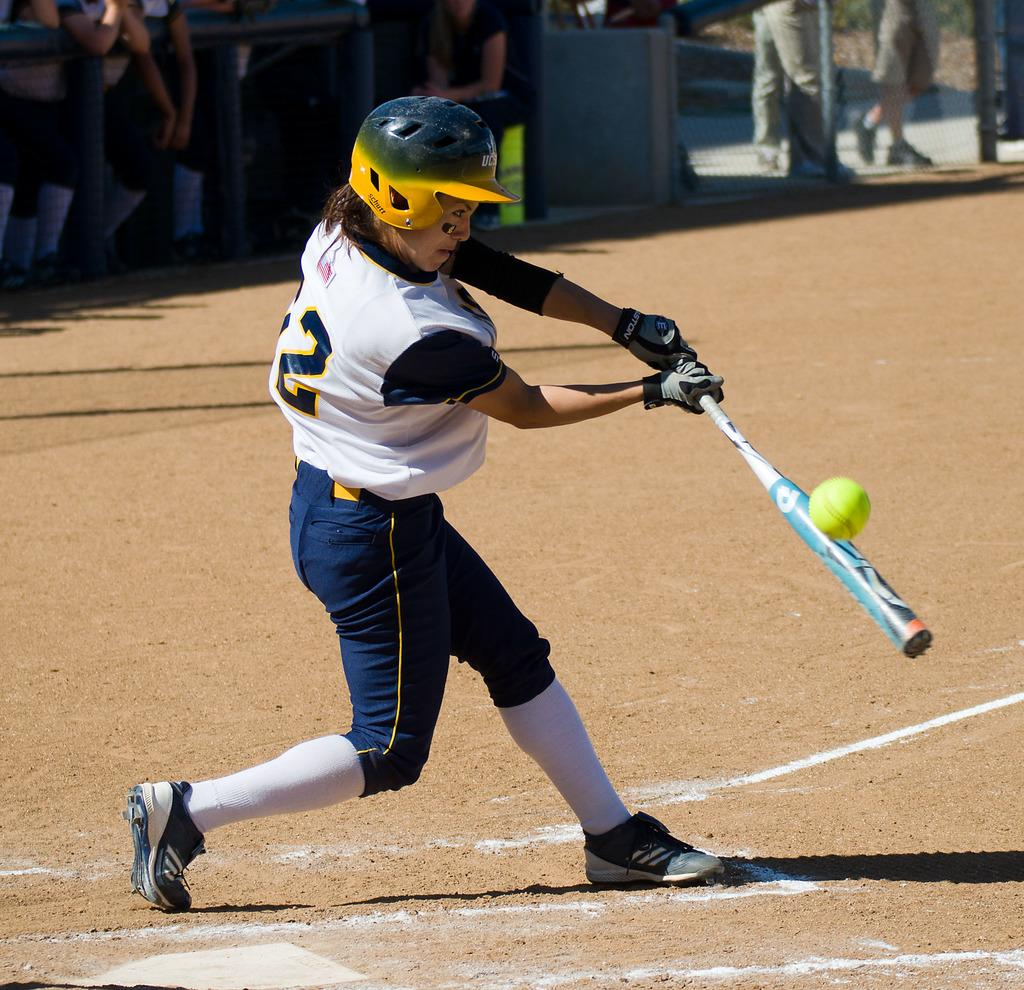What is the main subject of the image? There is a person in the image. What is the person holding in the image? The person is holding a bat. Can you describe the person's clothing in the image? The person is wearing a dress with different colors. What else can be seen in the image besides the person? There is a ball in the image. Are there any other people visible in the image? Yes, there are people visible in the background of the image. What word is being used by the person in the image? There is no word being used by the person in the image. --- Facts: 1. There is a person in the image. 2. The person is holding a book. 3. The book is open. 4. The person is sitting on a chair. 5. There is a table next to the person. 6. There is a lamp on the table. Absurd Topics: unicorn, rainbow, clouds Conversation: What is the main subject of the image? There is a person in the image. What is the person holding in the image? The person is holding a book. What can be observed about the book in the image? The book is open. What is the person's position in the image? The person is sitting on a chair. What is located next to the person in the image? There is a table next to the person. What object can be seen on the table in the image? There is a lamp on the table. Reasoning: Let's think step by step in order to produce the conversation. We start by identifying the main subject of the image, which is the person. Next, we describe what the person is holding, which is a book. Then, we observe the position of the person, noting that they are sitting on a chair. After that, we identify the object located next to the person, which is a table. Finally, we describe the object that can be seen on the table, which is a lamp. Absurd Question/Answer: How many unicorns can be seen playing in the rainbow clouds in the image? There are no unicorns, rainbow, or clouds present in the image. 